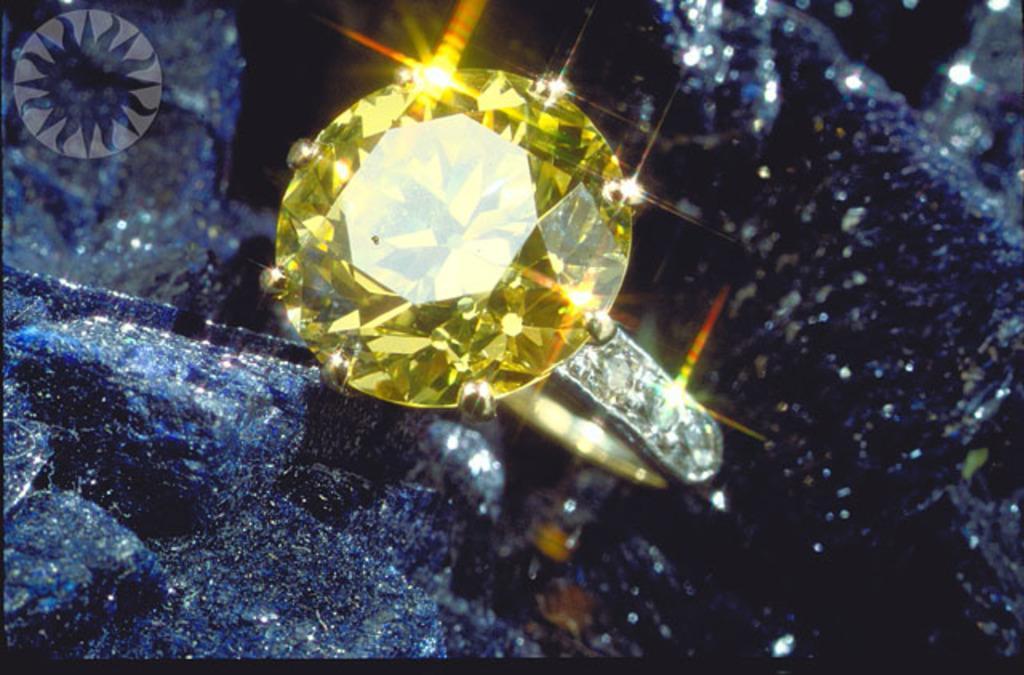Describe this image in one or two sentences. The picture consists of a diamond ring, in a cloth. The diamond is yellow color. 